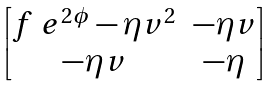<formula> <loc_0><loc_0><loc_500><loc_500>\begin{bmatrix} f \ e ^ { 2 \phi } - \eta v ^ { 2 } & - \eta v \\ - \eta v & - \eta \end{bmatrix}</formula> 